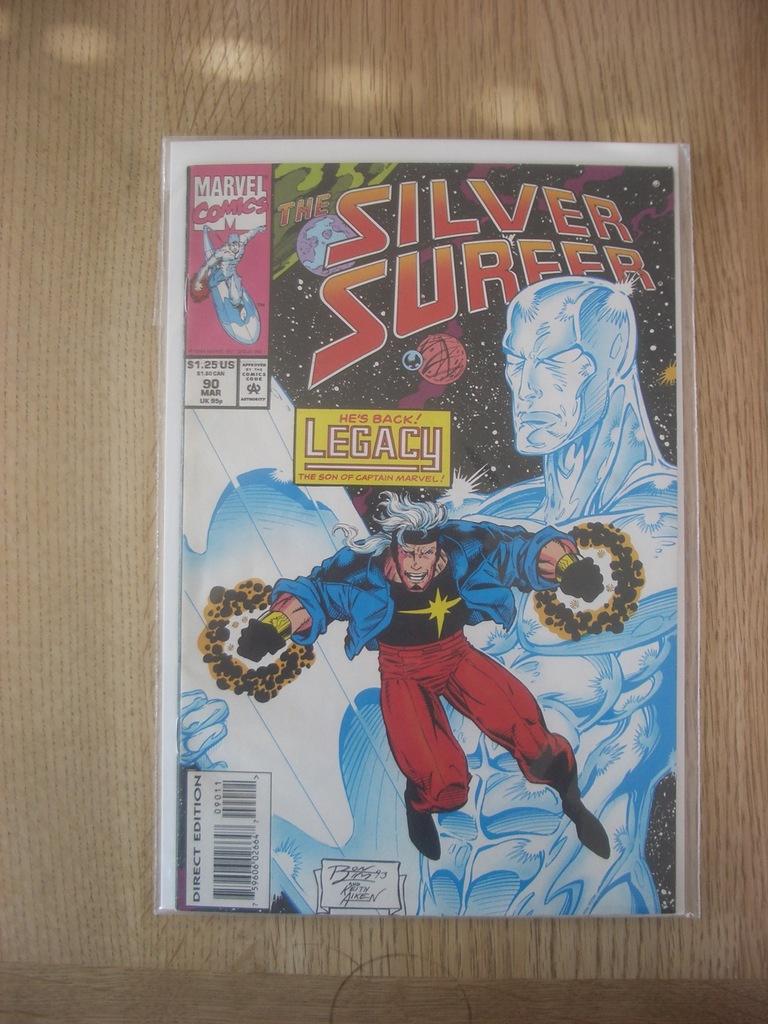What is the title of the comic book?
Ensure brevity in your answer.  Silver surfer. What big word appears in the yellow box?
Ensure brevity in your answer.  Legacy. 